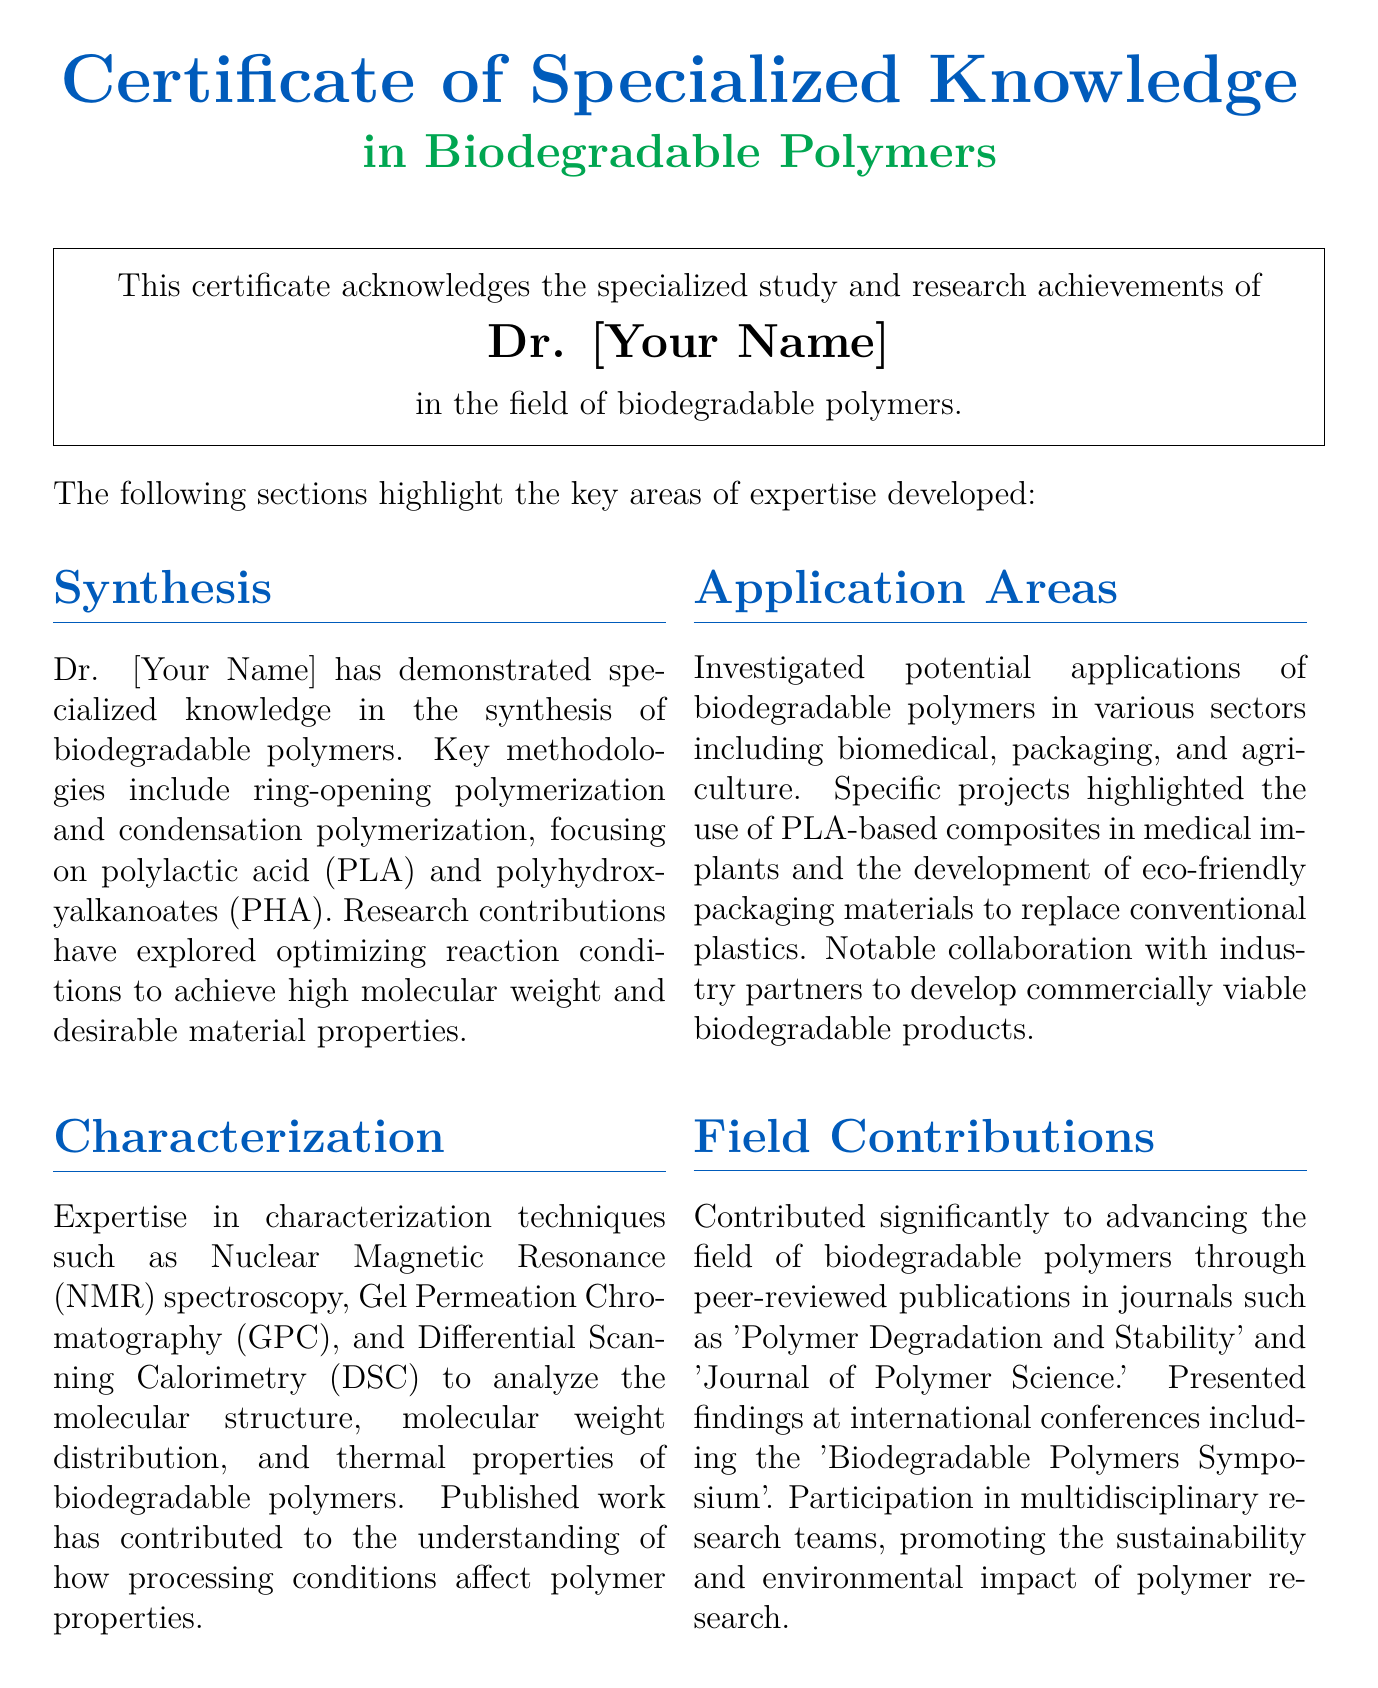What is the name of the individual awarded the certificate? The individual's name is mentioned explicitly in the certificate, presented as Dr. [Your Name].
Answer: Dr. [Your Name] What is the date of the award? The document specifies the date of the award at the bottom as October 15, 2023.
Answer: October 15, 2023 What is the specialization of the certificate? The title of the certificate indicates that it specializes in biodegradable polymers.
Answer: Biodegradable Polymers Which techniques are highlighted under characterization? The document lists specific characterization techniques used in the study of biodegradable polymers, including NMR, GPC, and DSC.
Answer: NMR, GPC, DSC What are the application areas mentioned for biodegradable polymers? The applications fields discussed in the certificate include biomedical, packaging, and agriculture.
Answer: Biomedical, packaging, agriculture Who is the director of the Polymer Research Institute? The document includes the name of the director, which is Professor Emily Brown.
Answer: Prof. Emily Brown What key methodologies are mentioned under synthesis? The synthesis section notes methodologies including ring-opening polymerization and condensation polymerization.
Answer: Ring-opening polymerization, condensation polymerization In which journals were research findings published? The certificate states two journals where publications appeared, namely 'Polymer Degradation and Stability' and 'Journal of Polymer Science.'
Answer: Polymer Degradation and Stability, Journal of Polymer Science What type of certificate is this document? The title indicates that the document is a certificate of specialized knowledge.
Answer: Certificate of Specialized Knowledge 